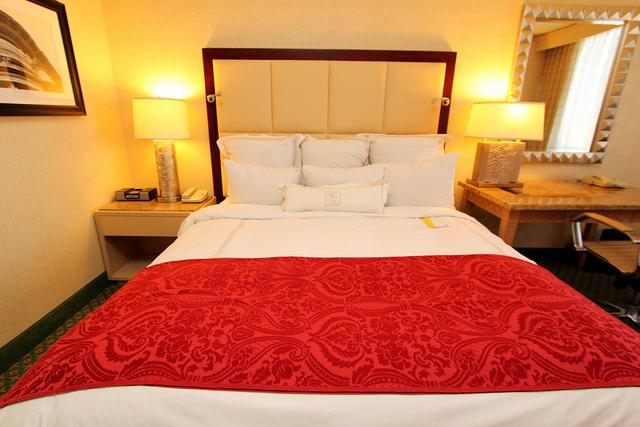What color is the bedding?
Be succinct. White. Are there pictures on the walls?
Concise answer only. Yes. Is this a  youth hostel?
Concise answer only. No. How many pillows are on the bed?
Keep it brief. 7. 